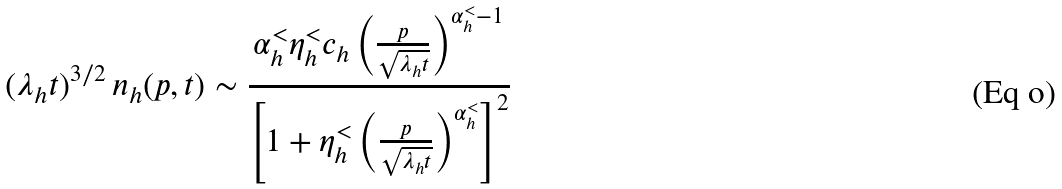Convert formula to latex. <formula><loc_0><loc_0><loc_500><loc_500>( \lambda _ { h } t ) ^ { 3 / 2 } \, n _ { h } ( p , t ) \sim \frac { \alpha ^ { < } _ { h } \eta ^ { < } _ { h } c _ { h } \left ( \frac { p } { \sqrt { \lambda _ { h } t } } \right ) ^ { \alpha ^ { < } _ { h } - 1 } } { \left [ 1 + \eta ^ { < } _ { h } \left ( \frac { p } { \sqrt { \lambda _ { h } t } } \right ) ^ { \alpha ^ { < } _ { h } } \right ] ^ { 2 } }</formula> 